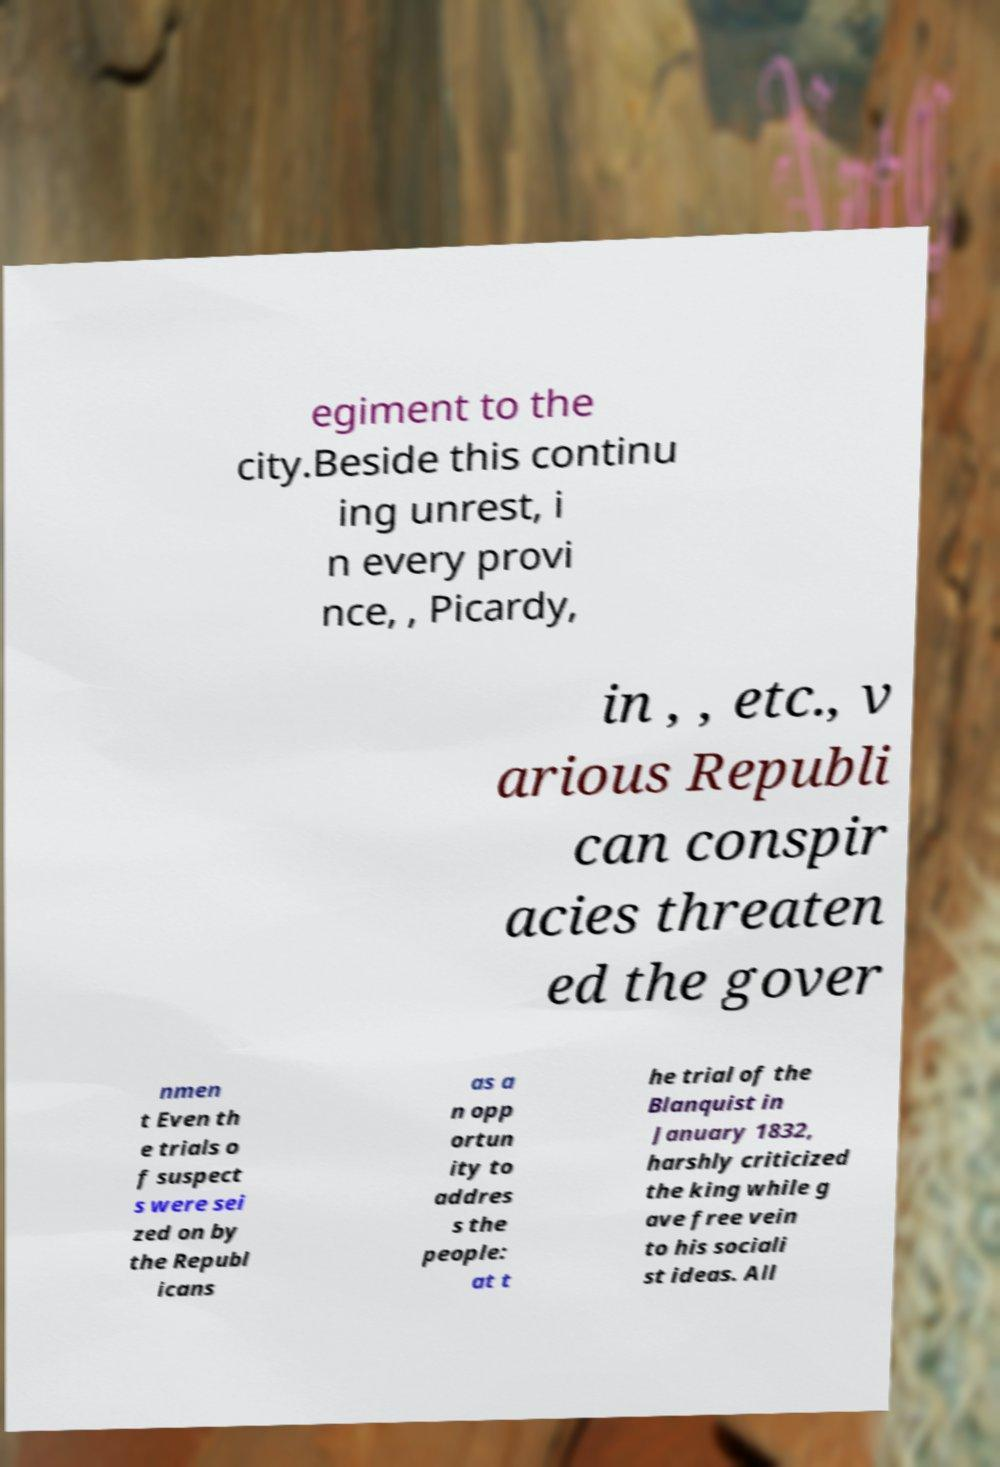Please read and relay the text visible in this image. What does it say? egiment to the city.Beside this continu ing unrest, i n every provi nce, , Picardy, in , , etc., v arious Republi can conspir acies threaten ed the gover nmen t Even th e trials o f suspect s were sei zed on by the Republ icans as a n opp ortun ity to addres s the people: at t he trial of the Blanquist in January 1832, harshly criticized the king while g ave free vein to his sociali st ideas. All 